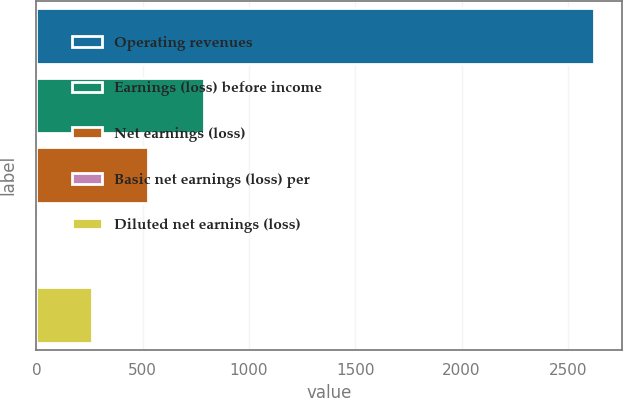Convert chart to OTSL. <chart><loc_0><loc_0><loc_500><loc_500><bar_chart><fcel>Operating revenues<fcel>Earnings (loss) before income<fcel>Net earnings (loss)<fcel>Basic net earnings (loss) per<fcel>Diluted net earnings (loss)<nl><fcel>2624<fcel>787.56<fcel>525.21<fcel>0.51<fcel>262.86<nl></chart> 